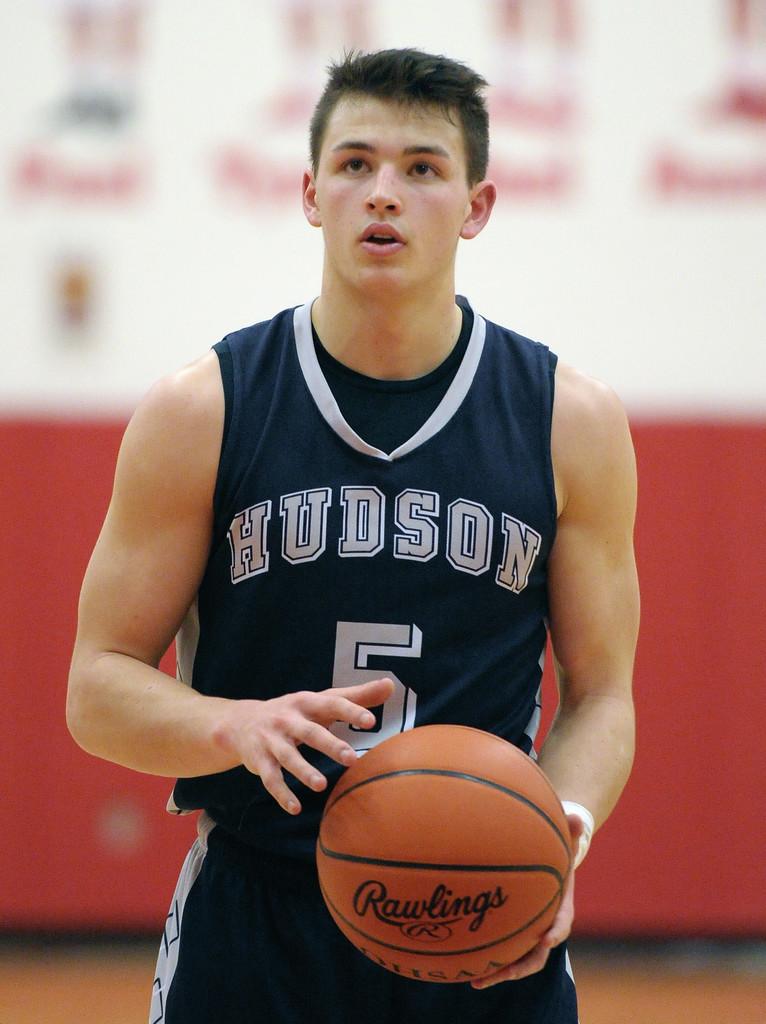What is this player's number?
Provide a succinct answer. 5. 